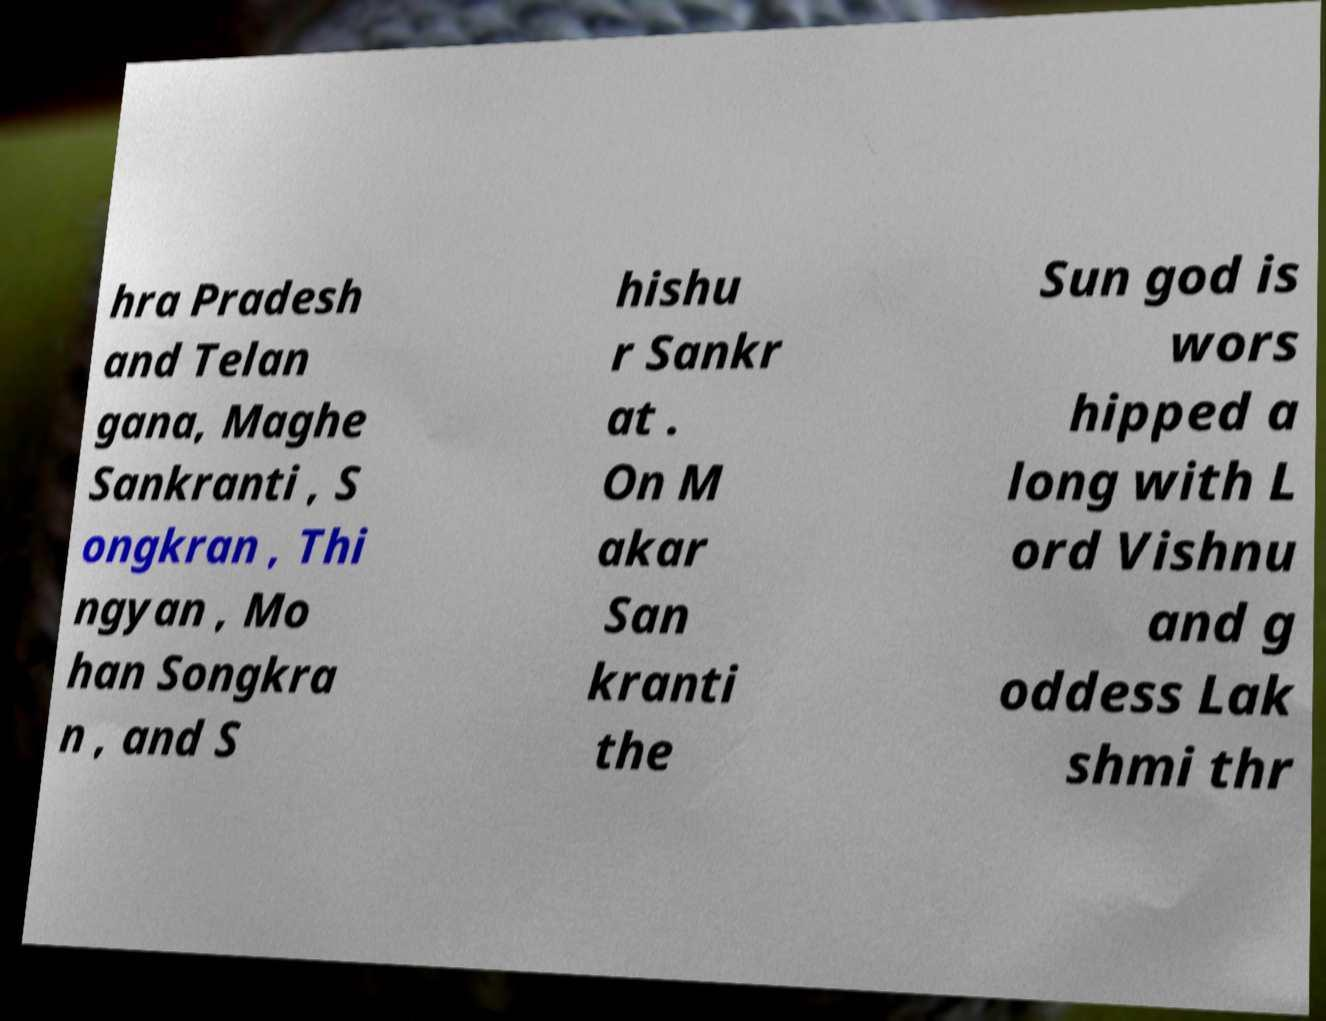Please read and relay the text visible in this image. What does it say? hra Pradesh and Telan gana, Maghe Sankranti , S ongkran , Thi ngyan , Mo han Songkra n , and S hishu r Sankr at . On M akar San kranti the Sun god is wors hipped a long with L ord Vishnu and g oddess Lak shmi thr 